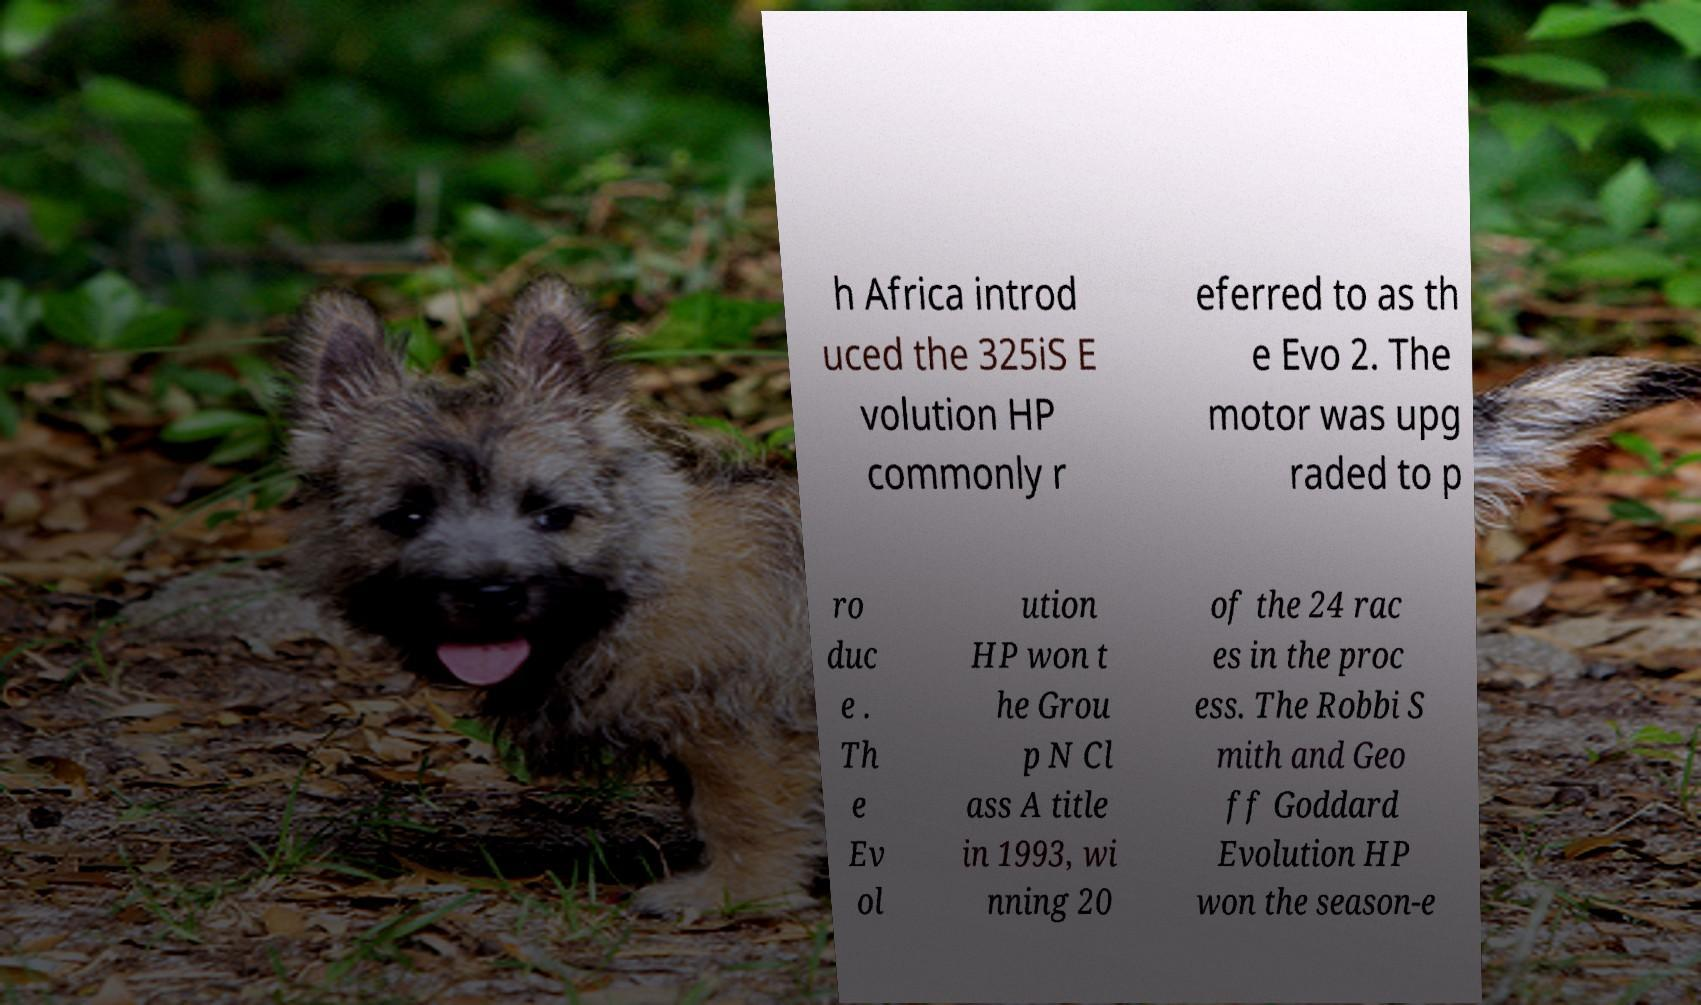Please identify and transcribe the text found in this image. h Africa introd uced the 325iS E volution HP commonly r eferred to as th e Evo 2. The motor was upg raded to p ro duc e . Th e Ev ol ution HP won t he Grou p N Cl ass A title in 1993, wi nning 20 of the 24 rac es in the proc ess. The Robbi S mith and Geo ff Goddard Evolution HP won the season-e 